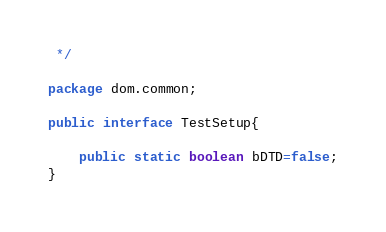<code> <loc_0><loc_0><loc_500><loc_500><_Java_> */

package dom.common;

public interface TestSetup{

    public static boolean bDTD=false;
}
</code> 